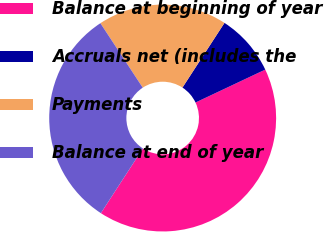<chart> <loc_0><loc_0><loc_500><loc_500><pie_chart><fcel>Balance at beginning of year<fcel>Accruals net (includes the<fcel>Payments<fcel>Balance at end of year<nl><fcel>41.19%<fcel>8.81%<fcel>18.42%<fcel>31.58%<nl></chart> 